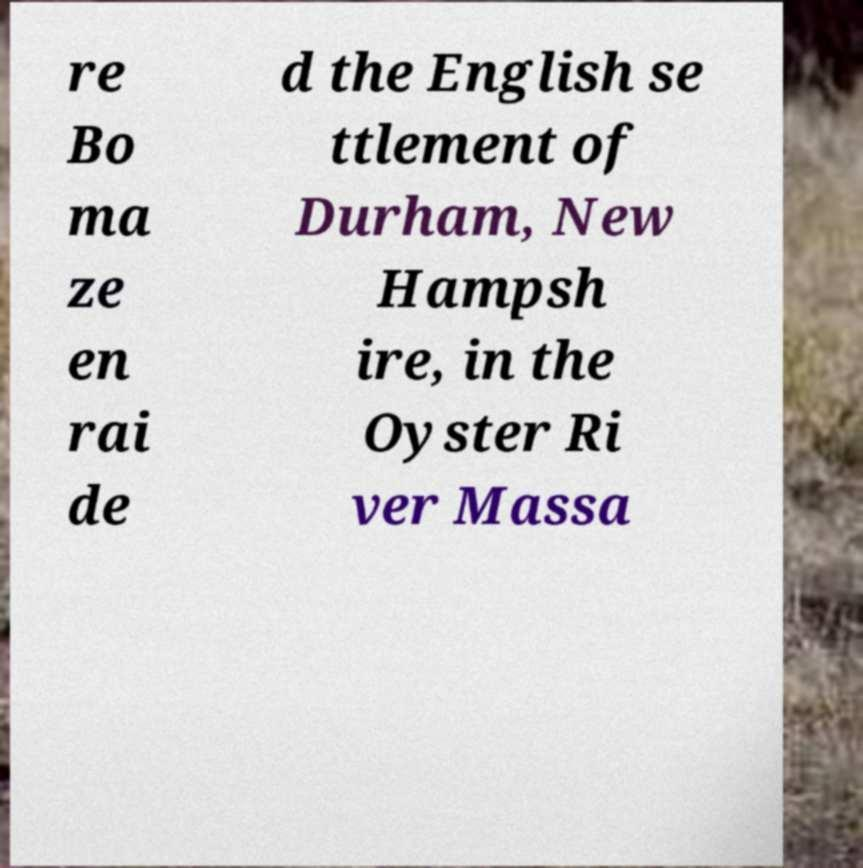There's text embedded in this image that I need extracted. Can you transcribe it verbatim? re Bo ma ze en rai de d the English se ttlement of Durham, New Hampsh ire, in the Oyster Ri ver Massa 